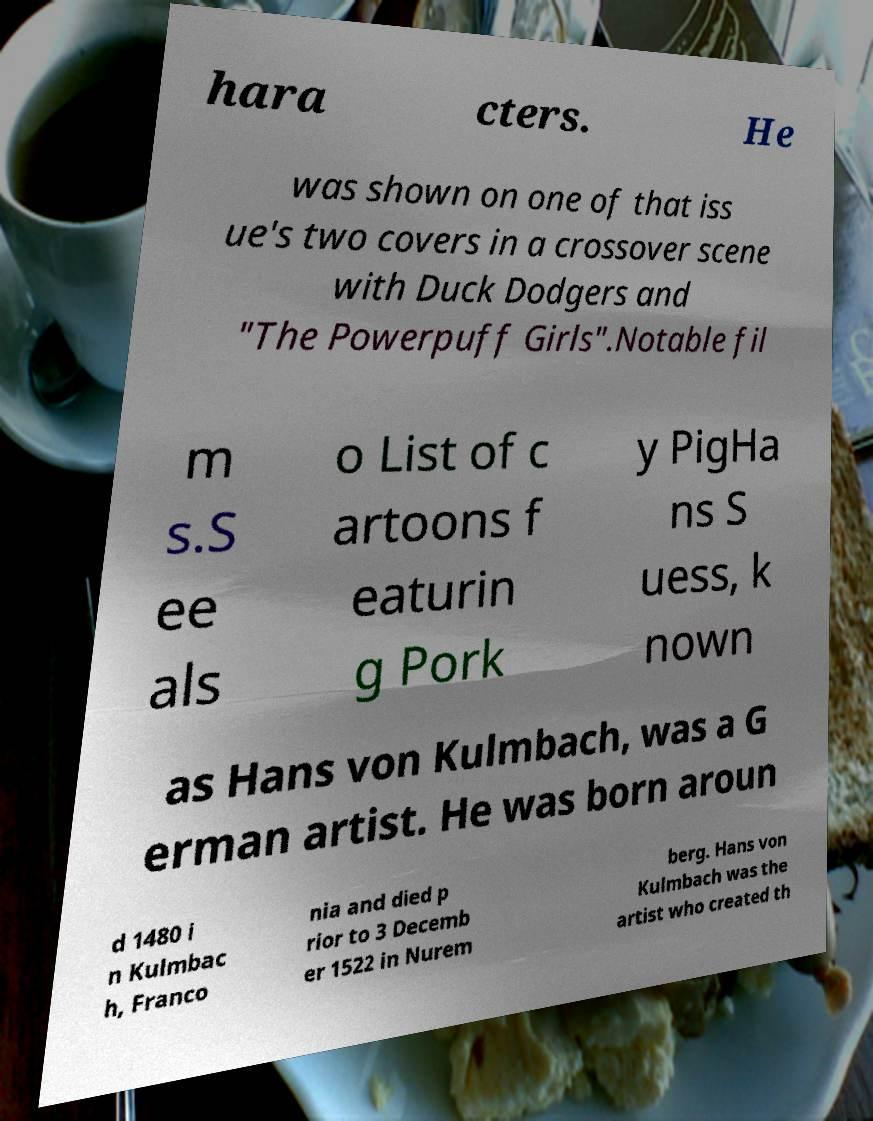Please read and relay the text visible in this image. What does it say? hara cters. He was shown on one of that iss ue's two covers in a crossover scene with Duck Dodgers and "The Powerpuff Girls".Notable fil m s.S ee als o List of c artoons f eaturin g Pork y PigHa ns S uess, k nown as Hans von Kulmbach, was a G erman artist. He was born aroun d 1480 i n Kulmbac h, Franco nia and died p rior to 3 Decemb er 1522 in Nurem berg. Hans von Kulmbach was the artist who created th 